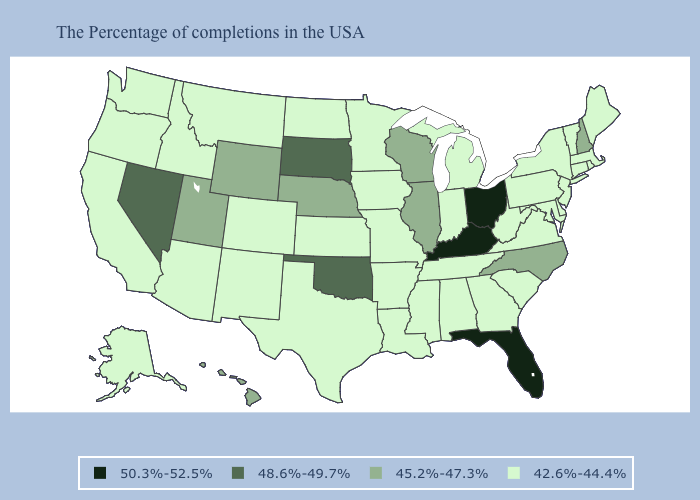Name the states that have a value in the range 48.6%-49.7%?
Write a very short answer. Oklahoma, South Dakota, Nevada. What is the lowest value in the USA?
Write a very short answer. 42.6%-44.4%. What is the highest value in the USA?
Quick response, please. 50.3%-52.5%. Which states hav the highest value in the MidWest?
Write a very short answer. Ohio. Does Ohio have the highest value in the MidWest?
Quick response, please. Yes. Name the states that have a value in the range 42.6%-44.4%?
Quick response, please. Maine, Massachusetts, Rhode Island, Vermont, Connecticut, New York, New Jersey, Delaware, Maryland, Pennsylvania, Virginia, South Carolina, West Virginia, Georgia, Michigan, Indiana, Alabama, Tennessee, Mississippi, Louisiana, Missouri, Arkansas, Minnesota, Iowa, Kansas, Texas, North Dakota, Colorado, New Mexico, Montana, Arizona, Idaho, California, Washington, Oregon, Alaska. What is the value of Illinois?
Be succinct. 45.2%-47.3%. Among the states that border Kentucky , which have the highest value?
Give a very brief answer. Ohio. What is the highest value in the West ?
Keep it brief. 48.6%-49.7%. What is the value of California?
Keep it brief. 42.6%-44.4%. Does Florida have the lowest value in the USA?
Quick response, please. No. Which states have the lowest value in the USA?
Concise answer only. Maine, Massachusetts, Rhode Island, Vermont, Connecticut, New York, New Jersey, Delaware, Maryland, Pennsylvania, Virginia, South Carolina, West Virginia, Georgia, Michigan, Indiana, Alabama, Tennessee, Mississippi, Louisiana, Missouri, Arkansas, Minnesota, Iowa, Kansas, Texas, North Dakota, Colorado, New Mexico, Montana, Arizona, Idaho, California, Washington, Oregon, Alaska. Among the states that border Montana , which have the highest value?
Keep it brief. South Dakota. Does New Hampshire have the same value as South Dakota?
Concise answer only. No. Name the states that have a value in the range 50.3%-52.5%?
Be succinct. Ohio, Florida, Kentucky. 